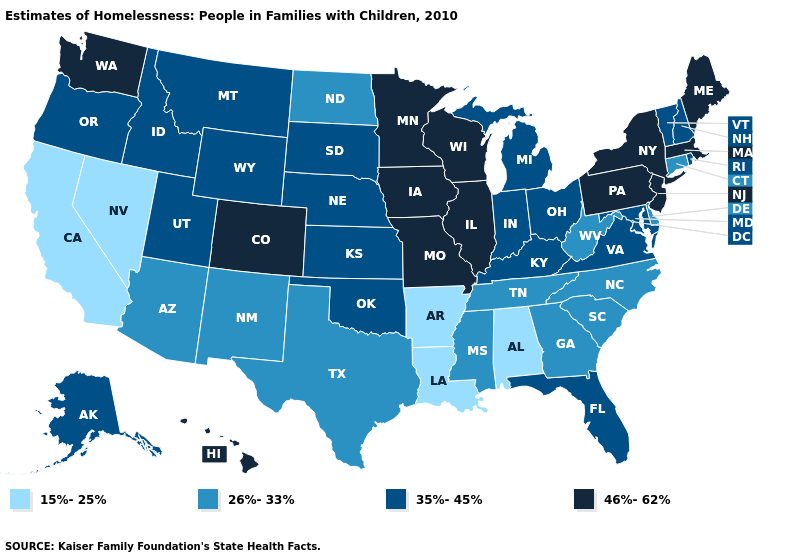Does the first symbol in the legend represent the smallest category?
Write a very short answer. Yes. What is the value of Delaware?
Keep it brief. 26%-33%. Does the first symbol in the legend represent the smallest category?
Write a very short answer. Yes. Name the states that have a value in the range 26%-33%?
Keep it brief. Arizona, Connecticut, Delaware, Georgia, Mississippi, New Mexico, North Carolina, North Dakota, South Carolina, Tennessee, Texas, West Virginia. What is the value of Ohio?
Answer briefly. 35%-45%. Name the states that have a value in the range 15%-25%?
Answer briefly. Alabama, Arkansas, California, Louisiana, Nevada. Name the states that have a value in the range 35%-45%?
Short answer required. Alaska, Florida, Idaho, Indiana, Kansas, Kentucky, Maryland, Michigan, Montana, Nebraska, New Hampshire, Ohio, Oklahoma, Oregon, Rhode Island, South Dakota, Utah, Vermont, Virginia, Wyoming. Does Wisconsin have the highest value in the USA?
Give a very brief answer. Yes. Among the states that border Idaho , does Washington have the lowest value?
Short answer required. No. What is the value of Oklahoma?
Quick response, please. 35%-45%. Which states hav the highest value in the Northeast?
Be succinct. Maine, Massachusetts, New Jersey, New York, Pennsylvania. Which states hav the highest value in the MidWest?
Answer briefly. Illinois, Iowa, Minnesota, Missouri, Wisconsin. What is the highest value in the South ?
Give a very brief answer. 35%-45%. Name the states that have a value in the range 26%-33%?
Answer briefly. Arizona, Connecticut, Delaware, Georgia, Mississippi, New Mexico, North Carolina, North Dakota, South Carolina, Tennessee, Texas, West Virginia. Does Nevada have the lowest value in the USA?
Answer briefly. Yes. 